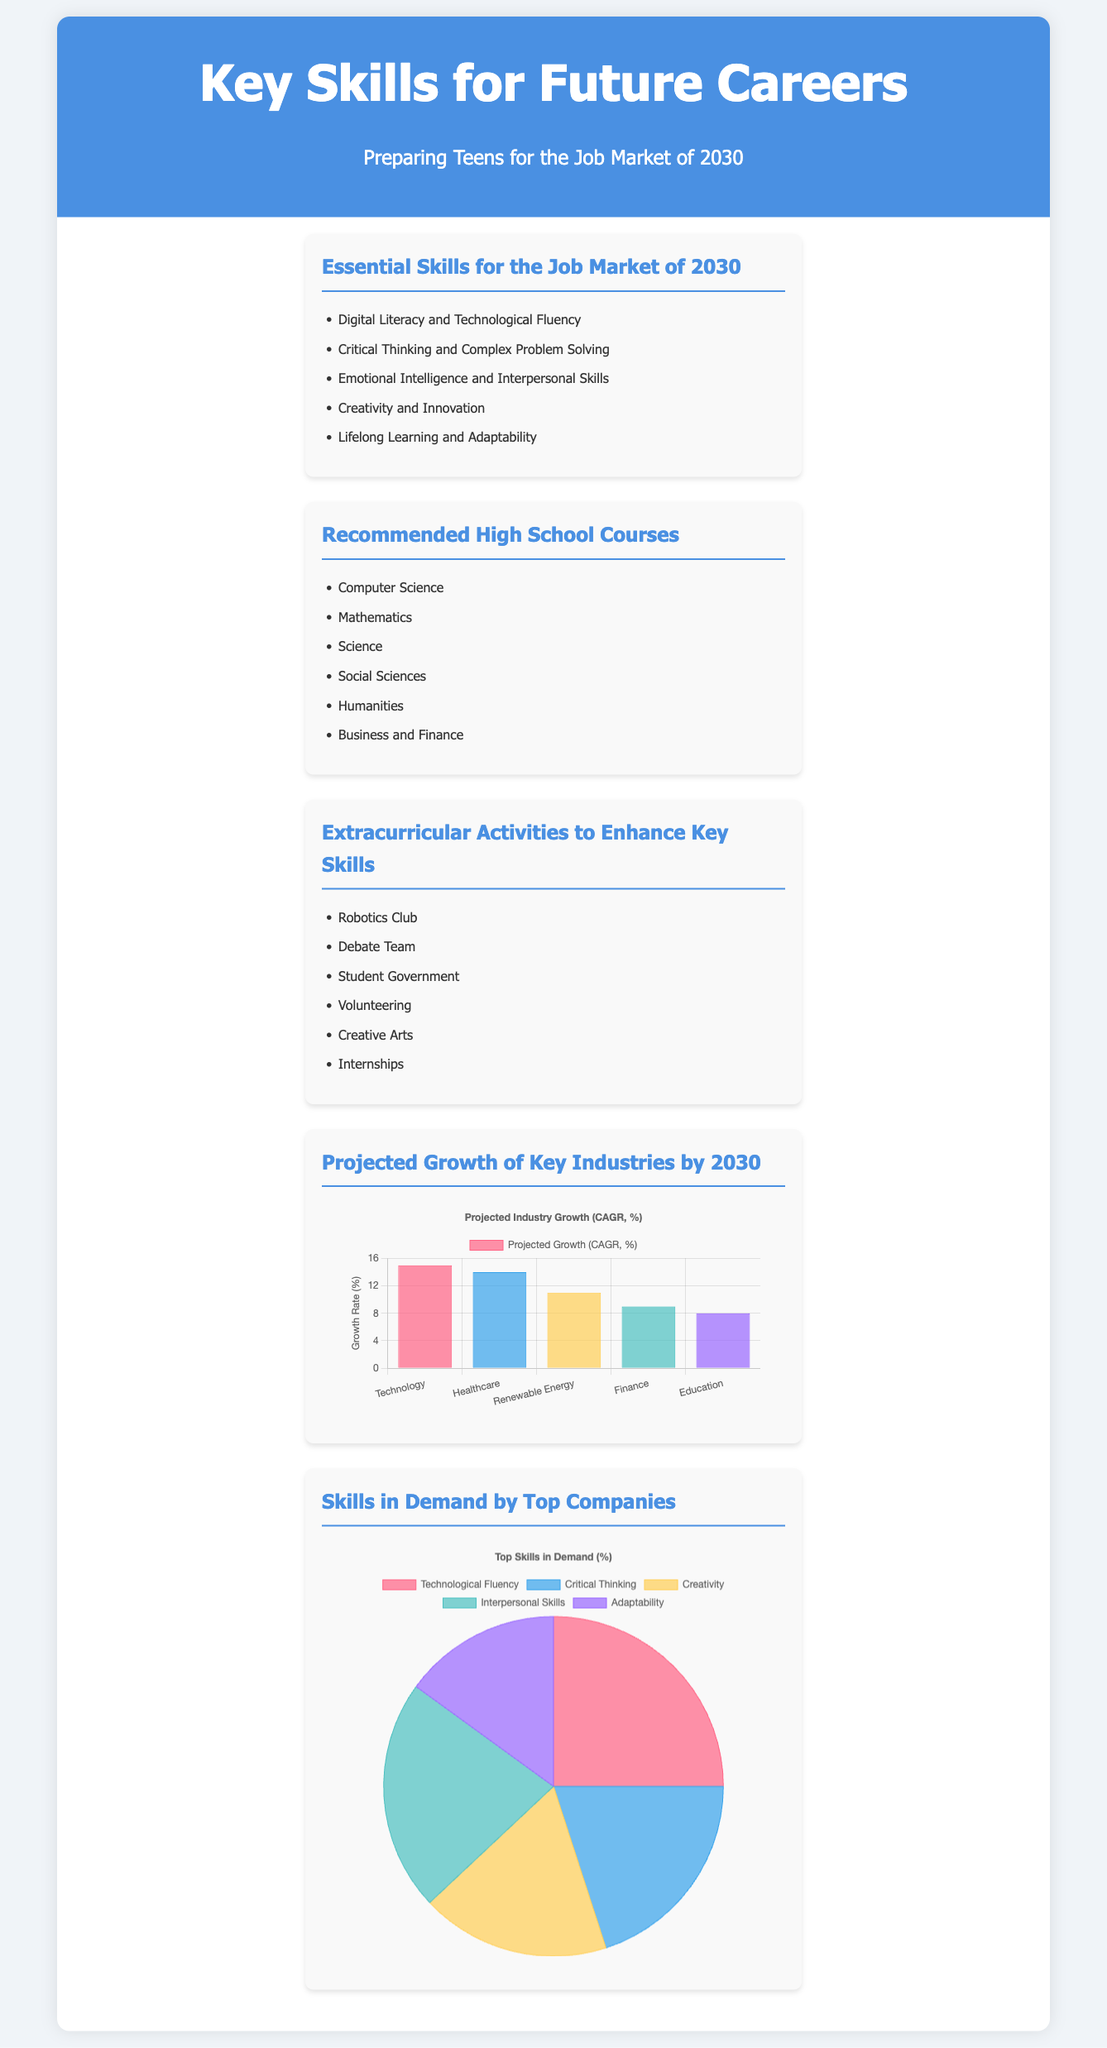what are the essential skills for the job market of 2030? The essential skills are listed in the first section and include Digital Literacy and Technological Fluency, Critical Thinking and Complex Problem Solving, Emotional Intelligence and Interpersonal Skills, Creativity and Innovation, and Lifelong Learning and Adaptability.
Answer: Digital Literacy and Technological Fluency, Critical Thinking and Complex Problem Solving, Emotional Intelligence and Interpersonal Skills, Creativity and Innovation, Lifelong Learning and Adaptability which high school course is specifically mentioned for preparing students? The recommended high school courses are listed in the second section, and Computer Science is one of them.
Answer: Computer Science what is the projected growth rate for the healthcare industry by 2030? The growth rate for the healthcare industry is indicated on the bar chart and is 14%.
Answer: 14% which skill is in the highest demand among top companies? The skills in demand are shown in a pie chart, and Technological Fluency has the largest portion.
Answer: Technological Fluency how many skills were surveyed for demand among top companies? The pie chart lists five skills in total that were measured for demand.
Answer: Five which extracurricular activity is related to technical skills? The list of extracurricular activities includes Robotics Club, which is associated with technical skills.
Answer: Robotics Club what industry has the lowest projected growth by 2030? The bar chart shows that Education has the lowest projected growth rate at 8%.
Answer: Education what percentage of demand does creativity have among the top skills? The pie chart indicates that Creativity represents 18% of the demand for top skills.
Answer: 18% 